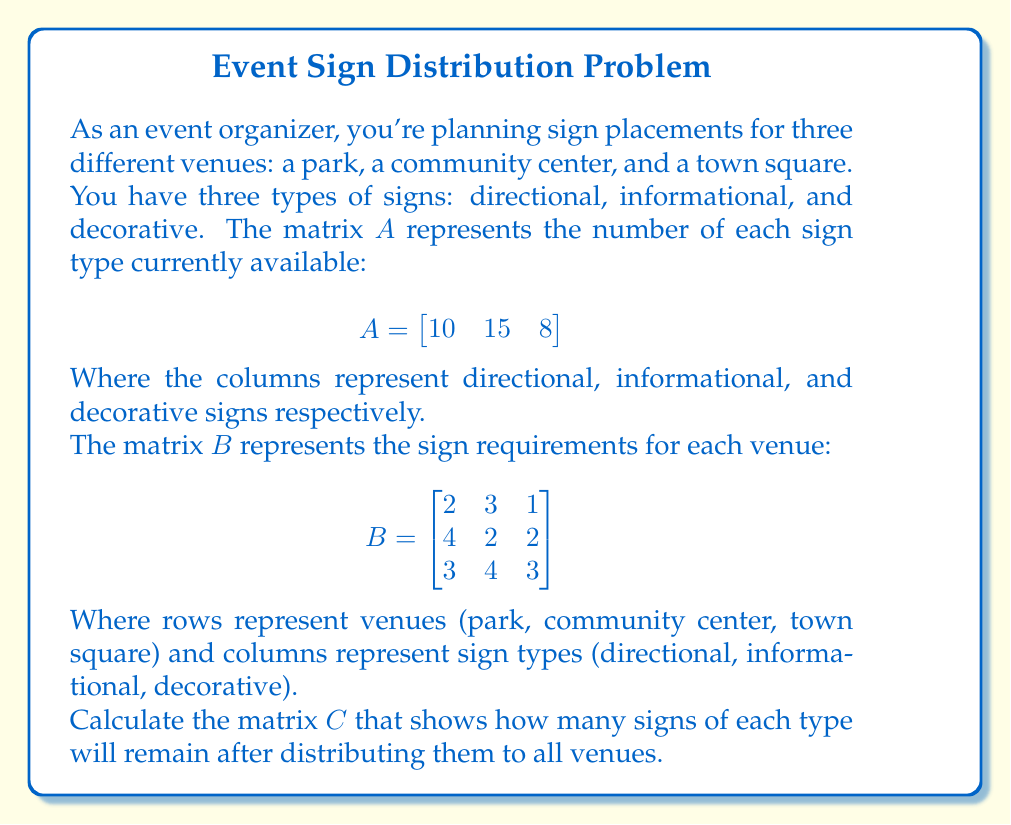Teach me how to tackle this problem. To solve this problem, we need to perform matrix subtraction. Here's the step-by-step process:

1) First, we need to calculate the total number of signs required for all venues. This can be done by summing the columns of matrix $B$:

   $$B_{total} = \begin{bmatrix}
   2+4+3 & 3+2+4 & 1+2+3
   \end{bmatrix} = \begin{bmatrix}
   9 & 9 & 6
   \end{bmatrix}$$

2) Now, we can subtract this total from the available signs matrix $A$:

   $$C = A - B_{total}$$

3) Performing the subtraction:

   $$C = \begin{bmatrix}
   10 & 15 & 8
   \end{bmatrix} - \begin{bmatrix}
   9 & 9 & 6
   \end{bmatrix}$$

   $$C = \begin{bmatrix}
   10-9 & 15-9 & 8-6
   \end{bmatrix}$$

4) Simplifying:

   $$C = \begin{bmatrix}
   1 & 6 & 2
   \end{bmatrix}$$

This result shows the number of signs remaining after distribution: 1 directional sign, 6 informational signs, and 2 decorative signs.
Answer: $C = \begin{bmatrix} 1 & 6 & 2 \end{bmatrix}$ 